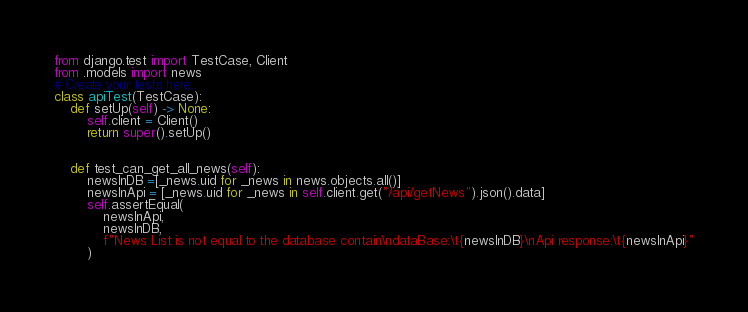Convert code to text. <code><loc_0><loc_0><loc_500><loc_500><_Python_>from django.test import TestCase, Client
from .models import news
# Create your tests here.
class apiTest(TestCase):
    def setUp(self) -> None:
        self.client = Client()
        return super().setUp()

        
    def test_can_get_all_news(self):
        newsInDB =[_news.uid for _news in news.objects.all()]
        newsInApi = [_news.uid for _news in self.client.get("/api/getNews").json().data]
        self.assertEqual(
            newsInApi,
            newsInDB,
            f"News List is not equal to the database contain\ndataBase:\t{newsInDB}\nApi response:\t{newsInApi}"
        )</code> 